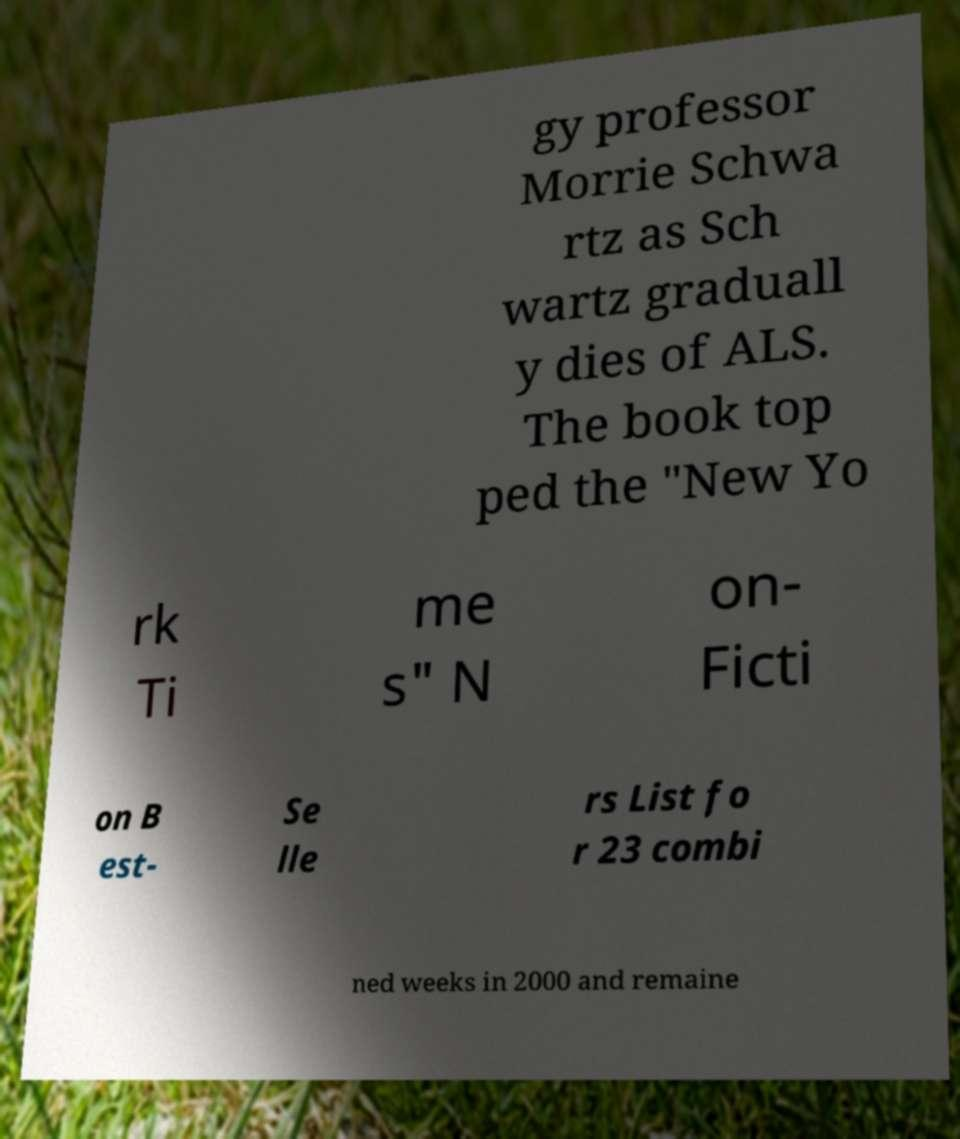Could you extract and type out the text from this image? gy professor Morrie Schwa rtz as Sch wartz graduall y dies of ALS. The book top ped the "New Yo rk Ti me s" N on- Ficti on B est- Se lle rs List fo r 23 combi ned weeks in 2000 and remaine 